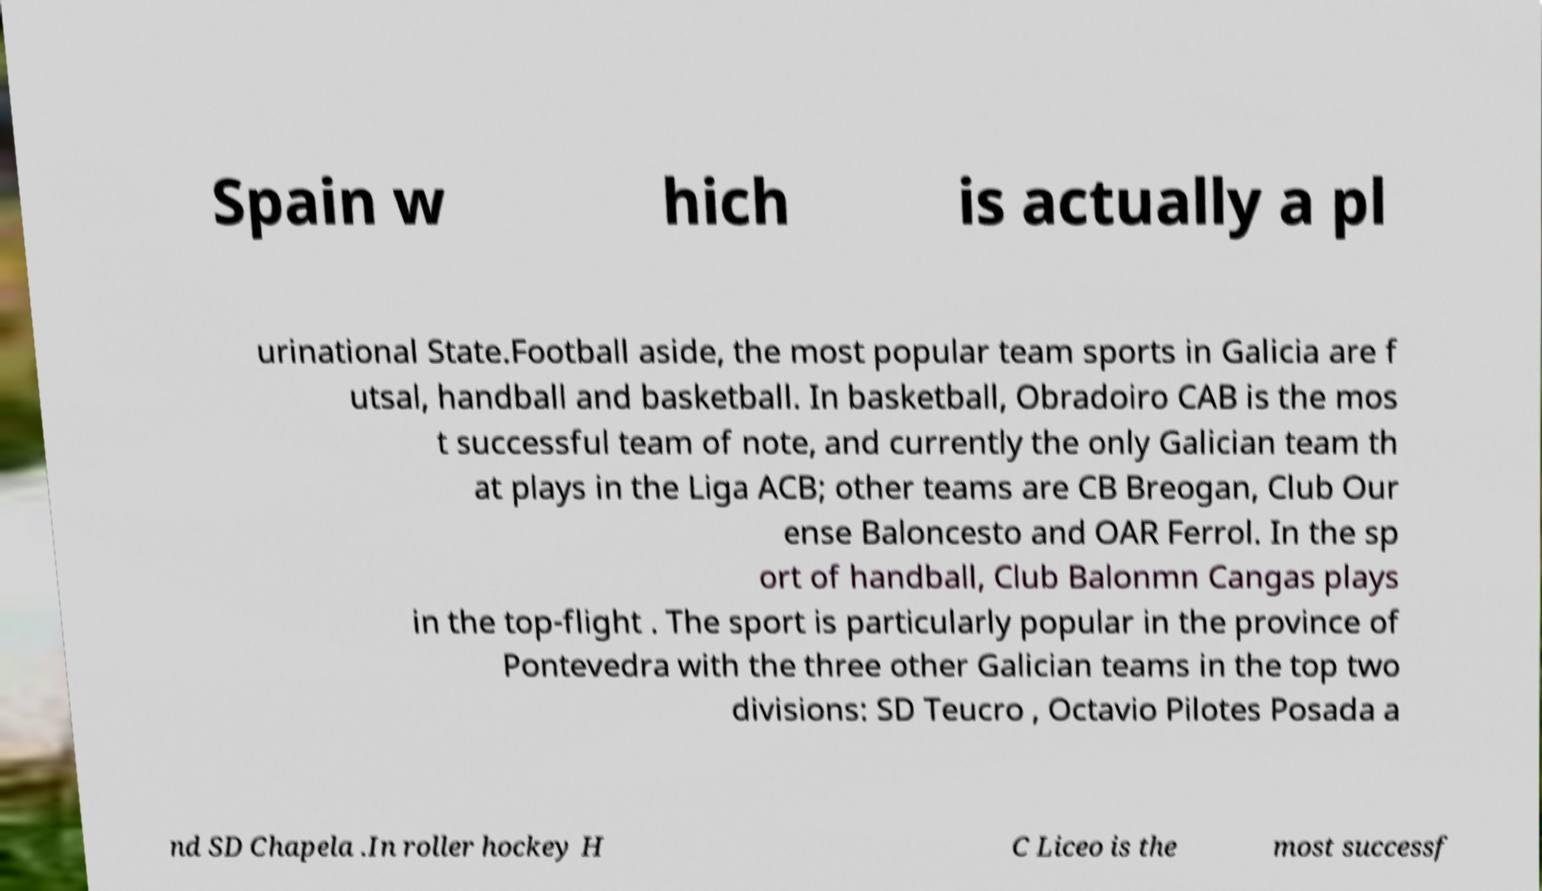For documentation purposes, I need the text within this image transcribed. Could you provide that? Spain w hich is actually a pl urinational State.Football aside, the most popular team sports in Galicia are f utsal, handball and basketball. In basketball, Obradoiro CAB is the mos t successful team of note, and currently the only Galician team th at plays in the Liga ACB; other teams are CB Breogan, Club Our ense Baloncesto and OAR Ferrol. In the sp ort of handball, Club Balonmn Cangas plays in the top-flight . The sport is particularly popular in the province of Pontevedra with the three other Galician teams in the top two divisions: SD Teucro , Octavio Pilotes Posada a nd SD Chapela .In roller hockey H C Liceo is the most successf 